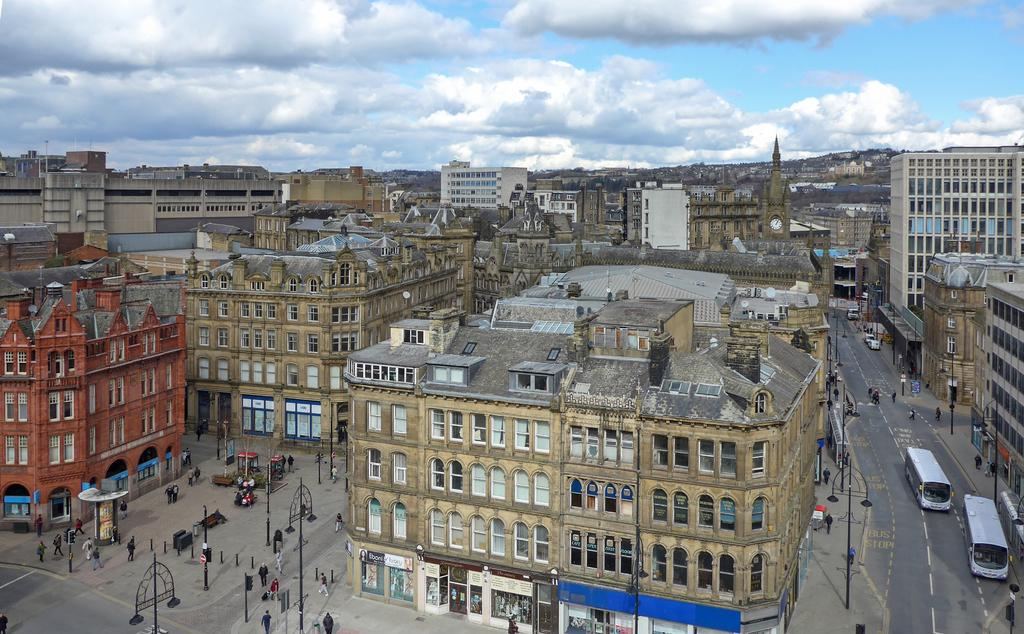What type of surface can be seen in the image? There is ground visible in the image. What is happening on the ground in the image? There are persons on the ground in the image. What structures are present in the image? There are poles, buildings, and a road in the image. What is moving along the road in the image? There are vehicles on the road in the image. What is visible in the background of the image? The sky is visible in the background of the image. Can you tell me if there is an agreement between the persons on the ground in the image? There is no information about an agreement between the persons in the image. Is there a sense of peace depicted in the image? The image does not convey a specific emotion or feeling, such as peace. 